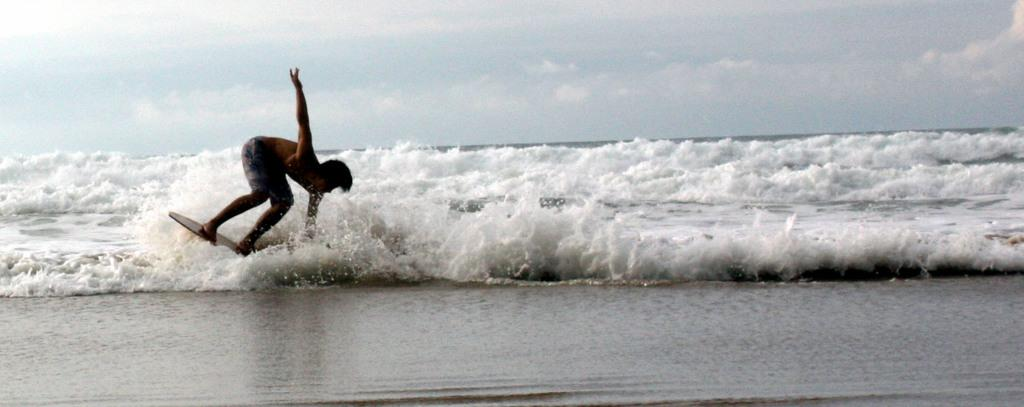Who is the main subject in the image? There is a man in the image. What is the man doing in the image? The man is surfing. What tool is the man using to surf? The man is using a surfboard. What type of environment is visible in the image? There is water visible in the image. What type of square can be seen in the image? There is no square present in the image. What order is the man following while surfing in the image? The image does not show the man following any specific order while surfing. 